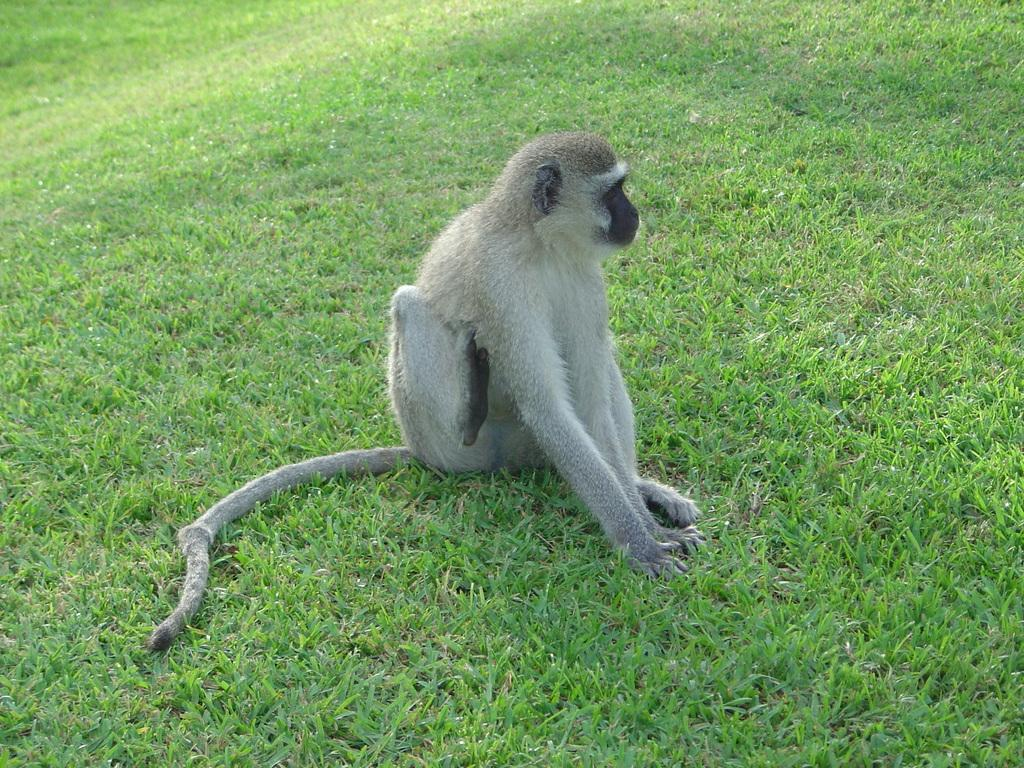What type of animal is in the image? There is a monkey in the image. What is the monkey standing on in the image? The monkey is on grassy land. What type of beast is visible in the image? There is no beast present in the image; it features a monkey. Can you tell me how many times the monkey kicks a fowl in the image? There is no fowl present in the image, and therefore no kicking action can be observed. 